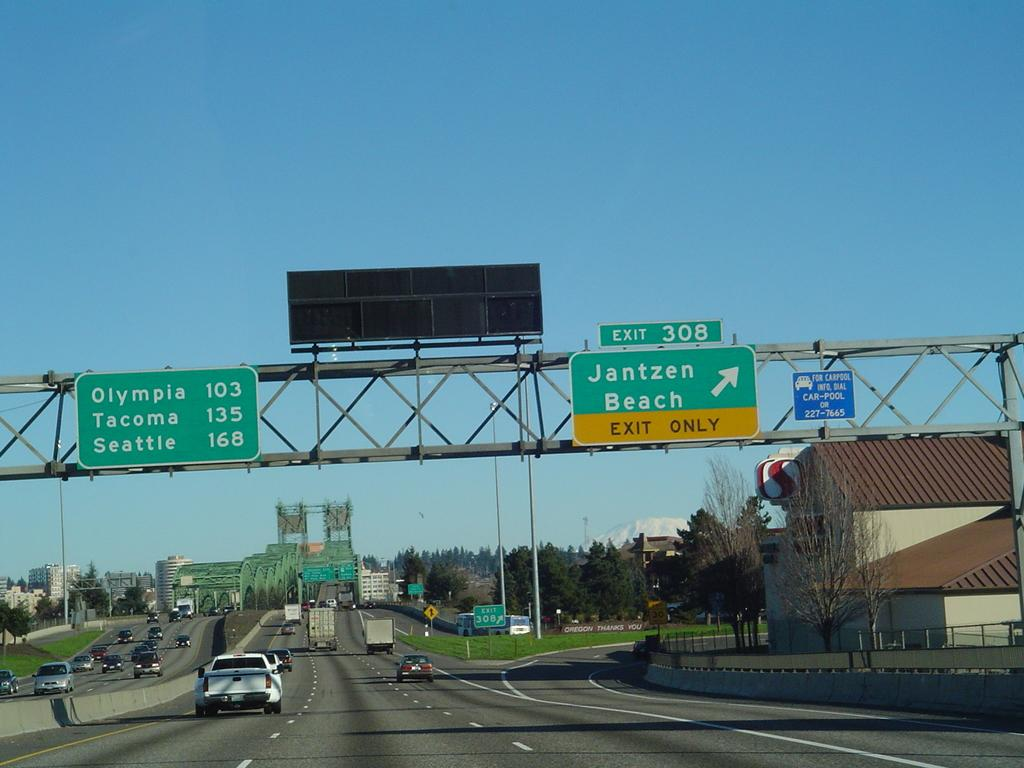<image>
Render a clear and concise summary of the photo. A highway scene showing that Exit 308 to Jantzen Beach is to the right.. 